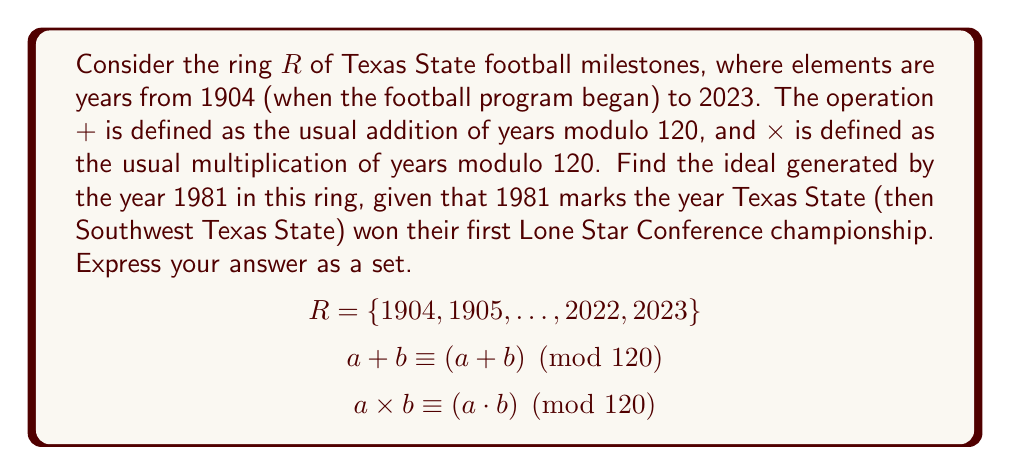Give your solution to this math problem. Let's approach this step-by-step:

1) In ring theory, the ideal generated by an element $a$ in a ring $R$ is denoted as $(a)$ and is defined as:

   $(a) = \{ra \mid r \in R\}$

2) In our case, $a = 1981$ and $R$ is the set of years from 1904 to 2023.

3) We need to find all multiples of 1981 in $R$, modulo 120 (since our ring operations are defined modulo 120).

4) Let's calculate the first few multiples of 1981 mod 120:
   
   $1981 \times 1 \equiv 61 \pmod{120}$
   $1981 \times 2 \equiv 2 \pmod{120}$
   $1981 \times 3 \equiv 63 \pmod{120}$
   $1981 \times 4 \equiv 4 \pmod{120}$
   ...

5) We can see a pattern forming. The even multiples give us even numbers from 2 to 120 (mod 120), and the odd multiples give us odd numbers from 1 to 119 (mod 120).

6) This means that the ideal generated by 1981 includes all numbers from 1 to 120.

7) In the context of our ring $R$, this translates to all years from 1904 to 2023.

Therefore, the ideal generated by 1981 is the entire ring $R$.
Answer: $\{1904, 1905, \ldots, 2022, 2023\}$ 